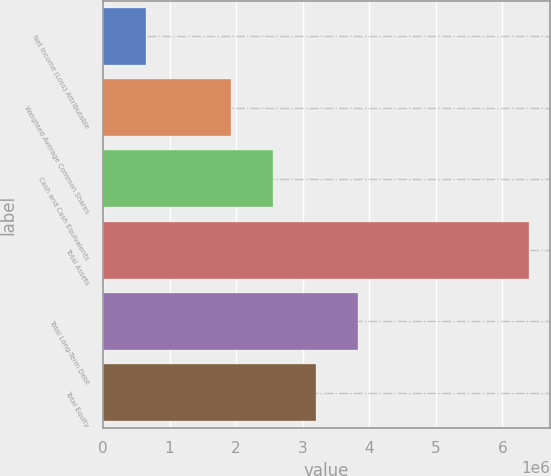Convert chart to OTSL. <chart><loc_0><loc_0><loc_500><loc_500><bar_chart><fcel>Net Income (Loss) Attributable<fcel>Weighted Average Common Shares<fcel>Cash and Cash Equivalents<fcel>Total Assets<fcel>Total Long-Term Debt<fcel>Total Equity<nl><fcel>639580<fcel>1.91874e+06<fcel>2.55832e+06<fcel>6.3958e+06<fcel>3.83748e+06<fcel>3.1979e+06<nl></chart> 